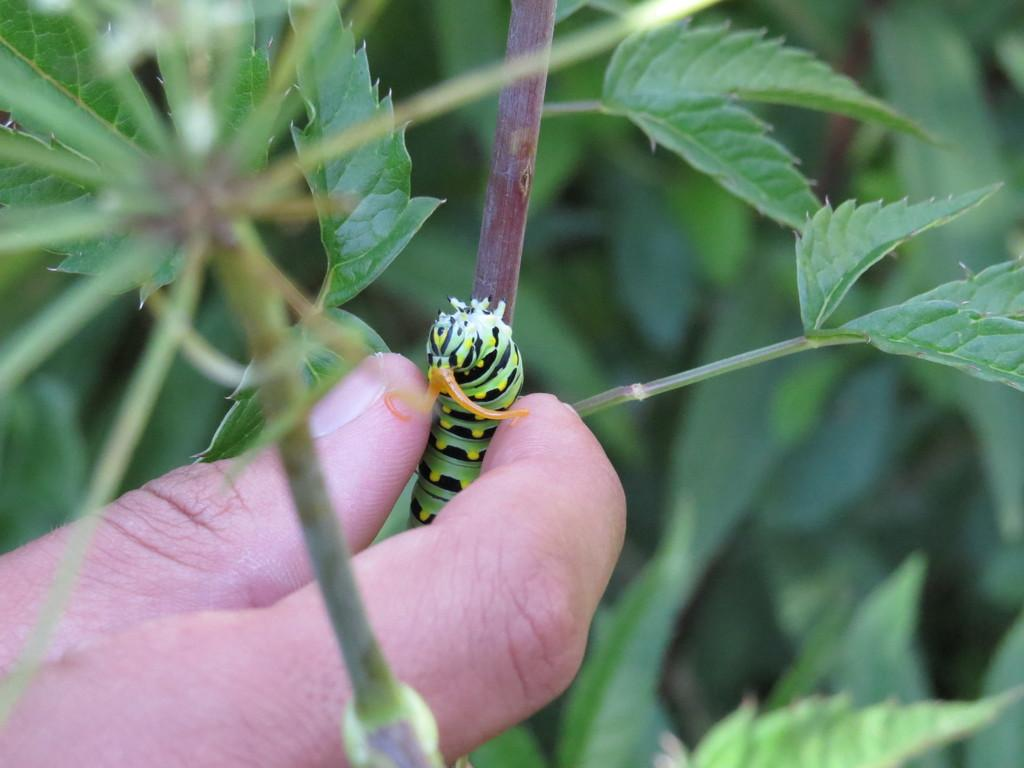What is the person's hand holding in the image? The person's hand is holding an insect in the image. Where is the insect located on the plant? The insect is on a plant in the image. What can be seen in the background of the image? The background of the image is greenery. What type of soup is being served in the image? There is no soup present in the image; it features a person's hand holding an insect on a plant with a background of greenery. 